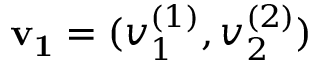<formula> <loc_0><loc_0><loc_500><loc_500>v _ { 1 } = ( v _ { 1 } ^ { ( 1 ) } , v _ { 2 } ^ { ( 2 ) } )</formula> 